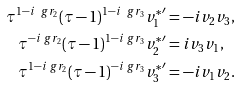Convert formula to latex. <formula><loc_0><loc_0><loc_500><loc_500>\tau ^ { 1 - i \ g r _ { 2 } } ( \tau - 1 ) ^ { 1 - i \ g r _ { 3 } } { v _ { 1 } ^ { * } } ^ { \prime } & = - i v _ { 2 } v _ { 3 } , \\ \tau ^ { - i \ g r _ { 2 } } ( \tau - 1 ) ^ { 1 - i \ g r _ { 3 } } { v _ { 2 } ^ { * } } ^ { \prime } & = i v _ { 3 } v _ { 1 } , \\ \tau ^ { 1 - i \ g r _ { 2 } } ( \tau - 1 ) ^ { - i \ g r _ { 3 } } { v _ { 3 } ^ { * } } ^ { \prime } & = - i v _ { 1 } v _ { 2 } .</formula> 